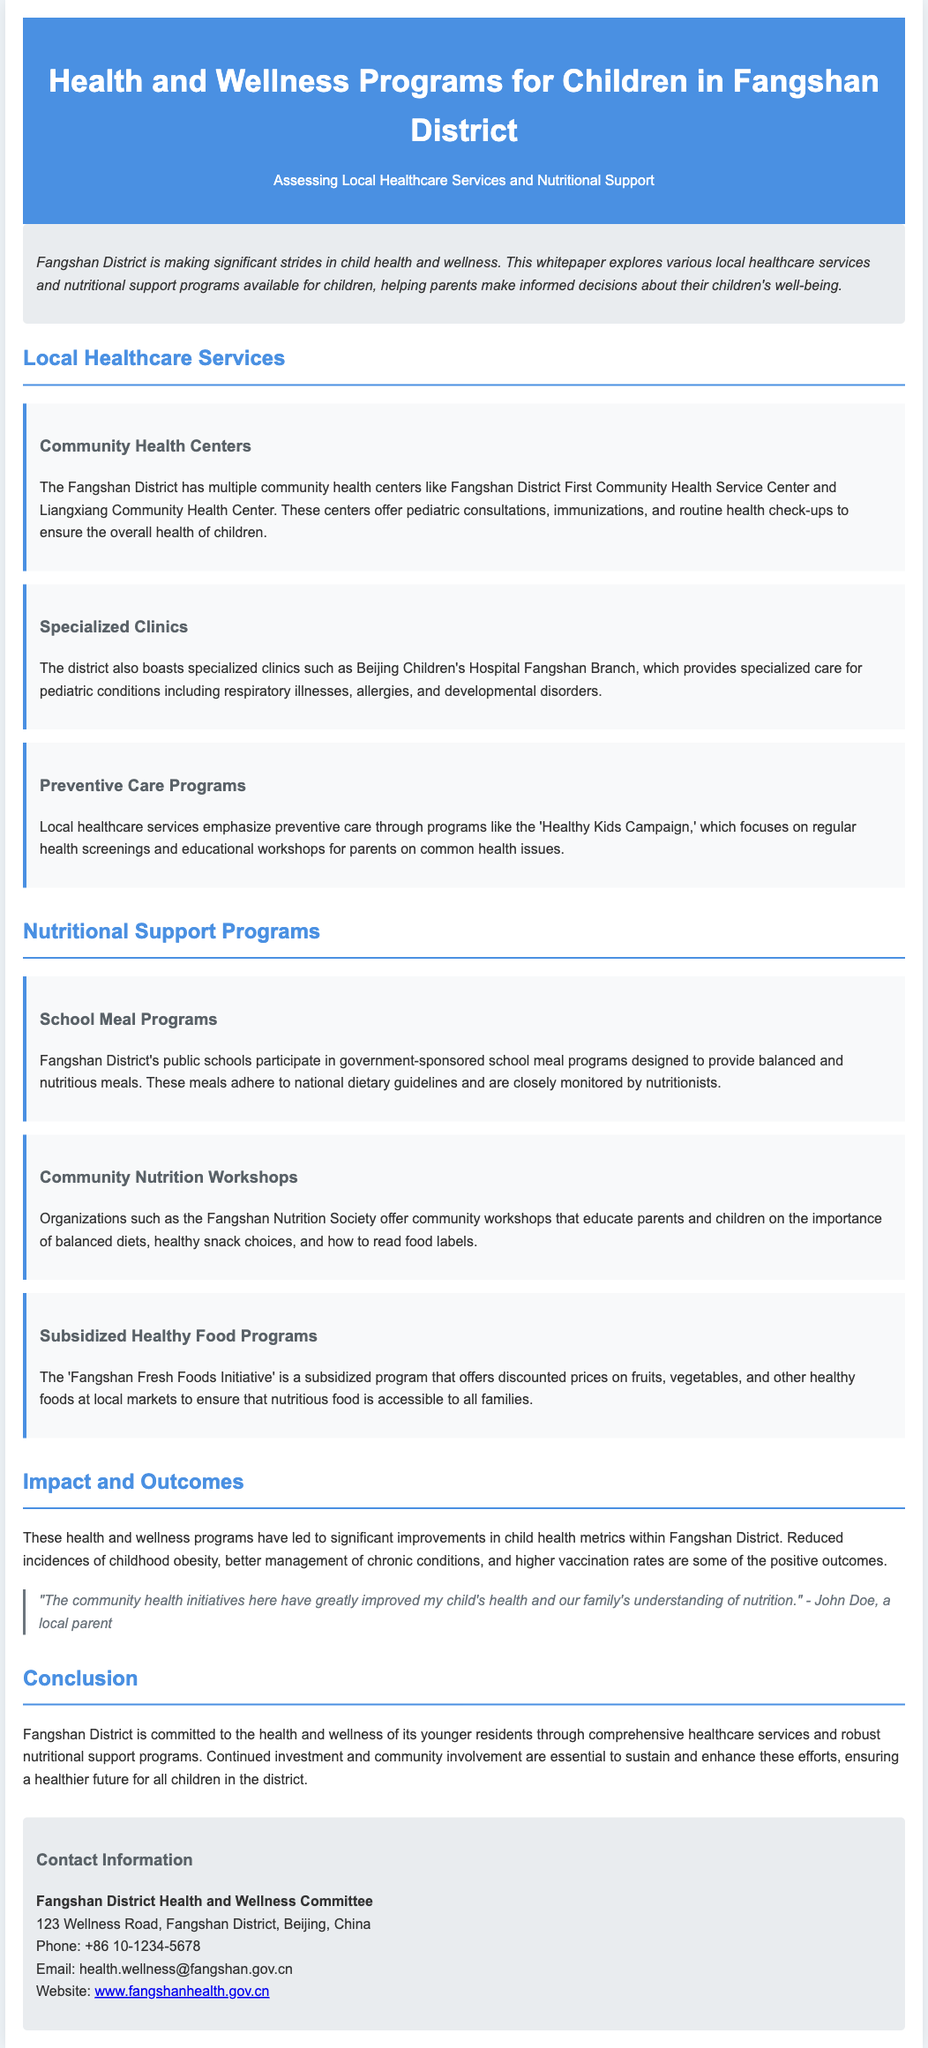what are the names of two community health centers in Fangshan District? The document lists Fangshan District First Community Health Service Center and Liangxiang Community Health Center as two community health centers.
Answer: Fangshan District First Community Health Service Center, Liangxiang Community Health Center what is the focus of the 'Healthy Kids Campaign'? The 'Healthy Kids Campaign' emphasizes preventive care through regular health screenings and educational workshops for parents.
Answer: Preventive care which hospital provides specialized pediatric care in Fangshan District? The document mentions Beijing Children's Hospital Fangshan Branch as the hospital that provides specialized pediatric care.
Answer: Beijing Children's Hospital Fangshan Branch how many types of nutritional support programs are mentioned in the document? There are three types of nutritional support programs discussed: School Meal Programs, Community Nutrition Workshops, and Subsidized Healthy Food Programs.
Answer: Three what significant health improvement is noted in Fangshan District? The document states there has been a reduction in incidences of childhood obesity as a significant health improvement.
Answer: Reduced incidences of childhood obesity who provided the impact quote in the document? The impact quote is attributed to John Doe, a local parent.
Answer: John Doe what is the location of the Fangshan District Health and Wellness Committee? The document lists the address as 123 Wellness Road, Fangshan District, Beijing, China.
Answer: 123 Wellness Road, Fangshan District, Beijing, China what is the email address for the Fangshan District Health and Wellness Committee? The email address provided in the document for the committee is health.wellness@fangshan.gov.cn.
Answer: health.wellness@fangshan.gov.cn what are the expected outcomes of the health and wellness programs in Fangshan District? The document mentions improved child health metrics including better management of chronic conditions and higher vaccination rates.
Answer: Improved child health metrics 